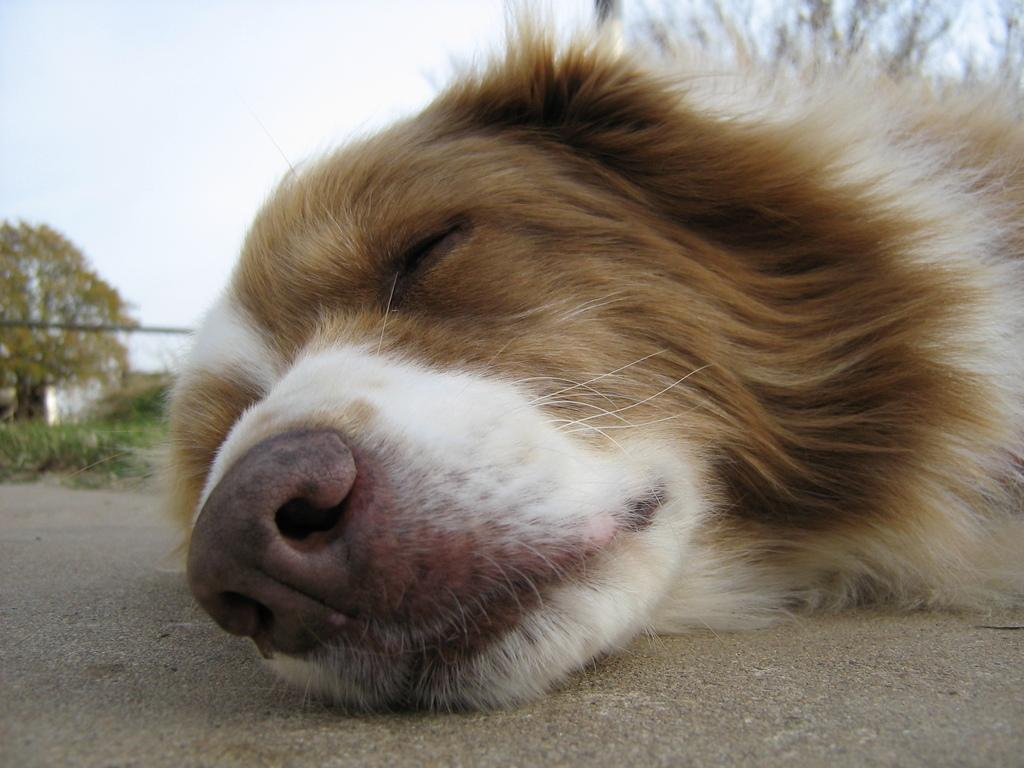What type of animal is in the image? There is a dog in the image. What is the dog doing in the image? The dog is lying on the ground. What can be seen in the background of the image? There is a tree, plants, and the sky visible in the background of the image. How many eggs are the dog holding in the image? There are no eggs present in the image; the dog is lying on the ground. 